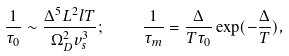<formula> <loc_0><loc_0><loc_500><loc_500>\frac { 1 } { \tau _ { 0 } } \sim \frac { \Delta ^ { 5 } L ^ { 2 } l T } { \Omega _ { D } ^ { 2 } v ^ { 3 } _ { s } } ; \quad \frac { 1 } { \tau _ { m } } = \frac { \Delta } { T \tau _ { 0 } } \exp ( - \frac { \Delta } { T } ) ,</formula> 